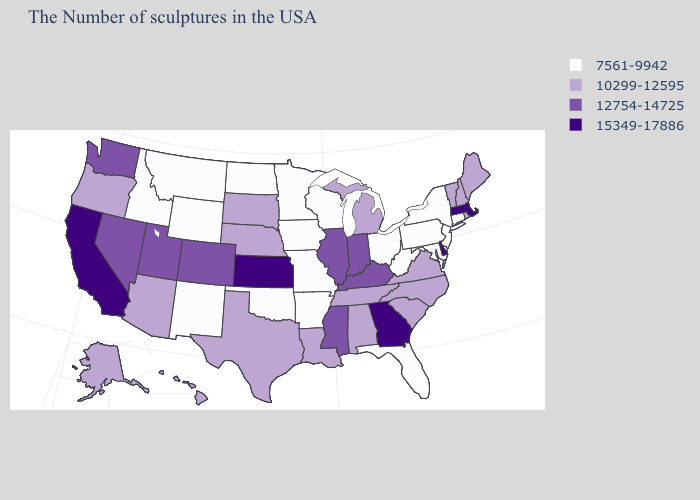Does Illinois have the same value as Kentucky?
Give a very brief answer. Yes. Does Delaware have the highest value in the USA?
Quick response, please. Yes. Among the states that border Nevada , which have the lowest value?
Answer briefly. Idaho. Does North Dakota have the highest value in the MidWest?
Concise answer only. No. What is the lowest value in states that border Arkansas?
Concise answer only. 7561-9942. Does the map have missing data?
Short answer required. No. What is the value of Delaware?
Short answer required. 15349-17886. What is the value of Iowa?
Write a very short answer. 7561-9942. Does Arizona have a higher value than Florida?
Be succinct. Yes. Does Colorado have a higher value than Arizona?
Be succinct. Yes. Does the map have missing data?
Write a very short answer. No. Name the states that have a value in the range 12754-14725?
Be succinct. Kentucky, Indiana, Illinois, Mississippi, Colorado, Utah, Nevada, Washington. Does Rhode Island have the same value as Alabama?
Answer briefly. Yes. Name the states that have a value in the range 12754-14725?
Concise answer only. Kentucky, Indiana, Illinois, Mississippi, Colorado, Utah, Nevada, Washington. What is the highest value in states that border Montana?
Write a very short answer. 10299-12595. 